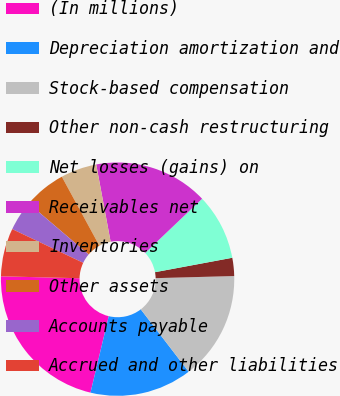<chart> <loc_0><loc_0><loc_500><loc_500><pie_chart><fcel>(In millions)<fcel>Depreciation amortization and<fcel>Stock-based compensation<fcel>Other non-cash restructuring<fcel>Net losses (gains) on<fcel>Receivables net<fcel>Inventories<fcel>Other assets<fcel>Accounts payable<fcel>Accrued and other liabilities<nl><fcel>21.66%<fcel>14.16%<fcel>15.0%<fcel>2.51%<fcel>9.17%<fcel>15.83%<fcel>5.0%<fcel>5.84%<fcel>4.17%<fcel>6.67%<nl></chart> 